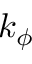Convert formula to latex. <formula><loc_0><loc_0><loc_500><loc_500>k _ { \phi }</formula> 